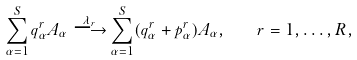<formula> <loc_0><loc_0><loc_500><loc_500>\sum _ { \alpha = 1 } ^ { S } q _ { \alpha } ^ { r } A _ { \alpha } \stackrel { \lambda _ { r } } { \longrightarrow } \sum _ { \alpha = 1 } ^ { S } ( q _ { \alpha } ^ { r } + p _ { \alpha } ^ { r } ) A _ { \alpha } , \quad r = 1 , \dots , R ,</formula> 